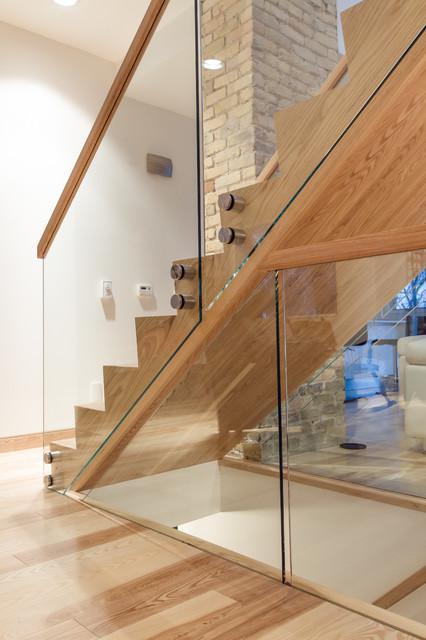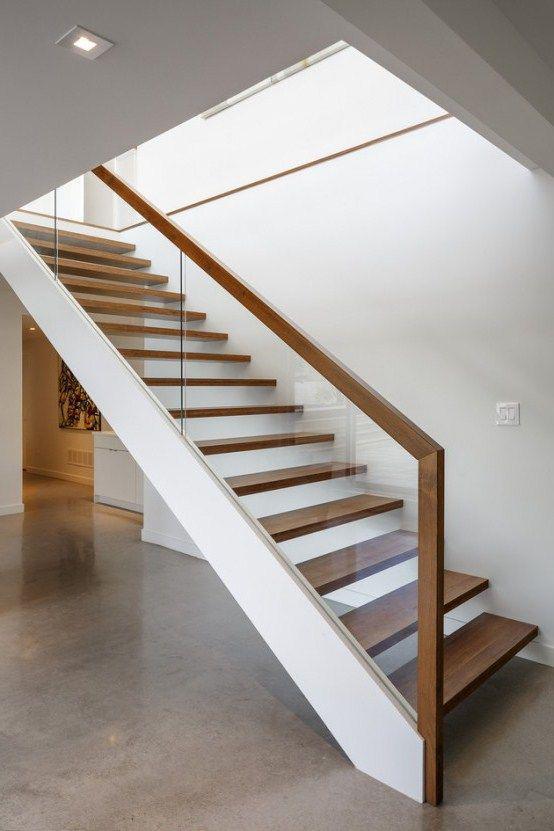The first image is the image on the left, the second image is the image on the right. Examine the images to the left and right. Is the description "The vertical posts on the stairway are all wood." accurate? Answer yes or no. No. The first image is the image on the left, the second image is the image on the right. Examine the images to the left and right. Is the description "One image shows a side view of stairs that ascend to the right and have a handrail with vertical supports spaced apart instead of close together." accurate? Answer yes or no. No. 